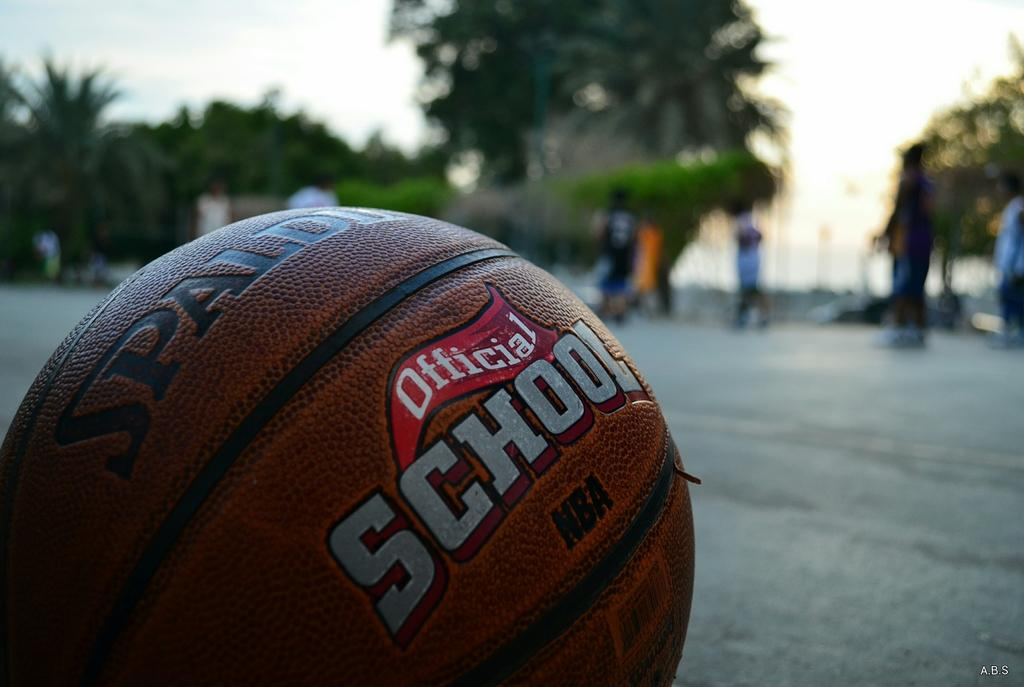What object is the main focus of the image? There is a ball in the image. How would you describe the background of the image? The background of the image is blurred. What can be seen in the distance in the image? There are trees, people, and the sky visible in the background. What type of transport is being used by the fork in the image? There is no fork present in the image, so this question cannot be answered. 